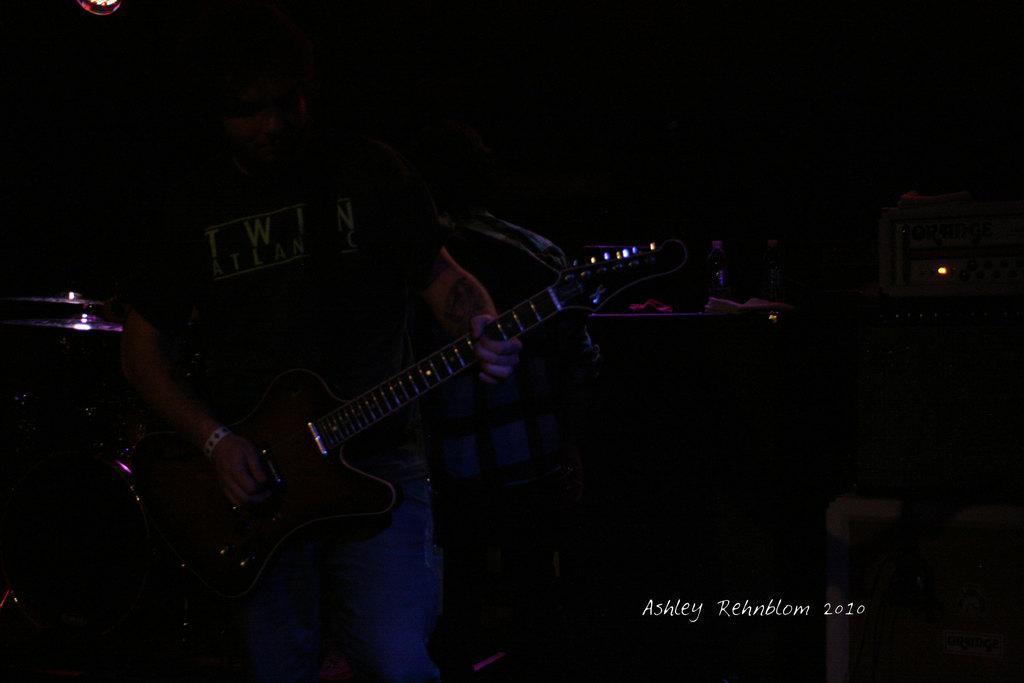Please provide a concise description of this image. in the picture we can see darkness,in which a person is standing and holding a guitar. 